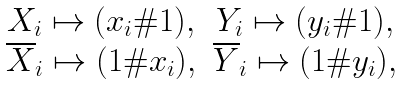Convert formula to latex. <formula><loc_0><loc_0><loc_500><loc_500>\begin{matrix} & X _ { i } \mapsto ( x _ { i } \# 1 ) , & Y _ { i } \mapsto ( y _ { i } \# 1 ) , \\ & \overline { X } _ { i } \mapsto ( 1 \# x _ { i } ) , & \overline { Y } _ { i } \mapsto ( 1 \# y _ { i } ) , \\ \end{matrix}</formula> 